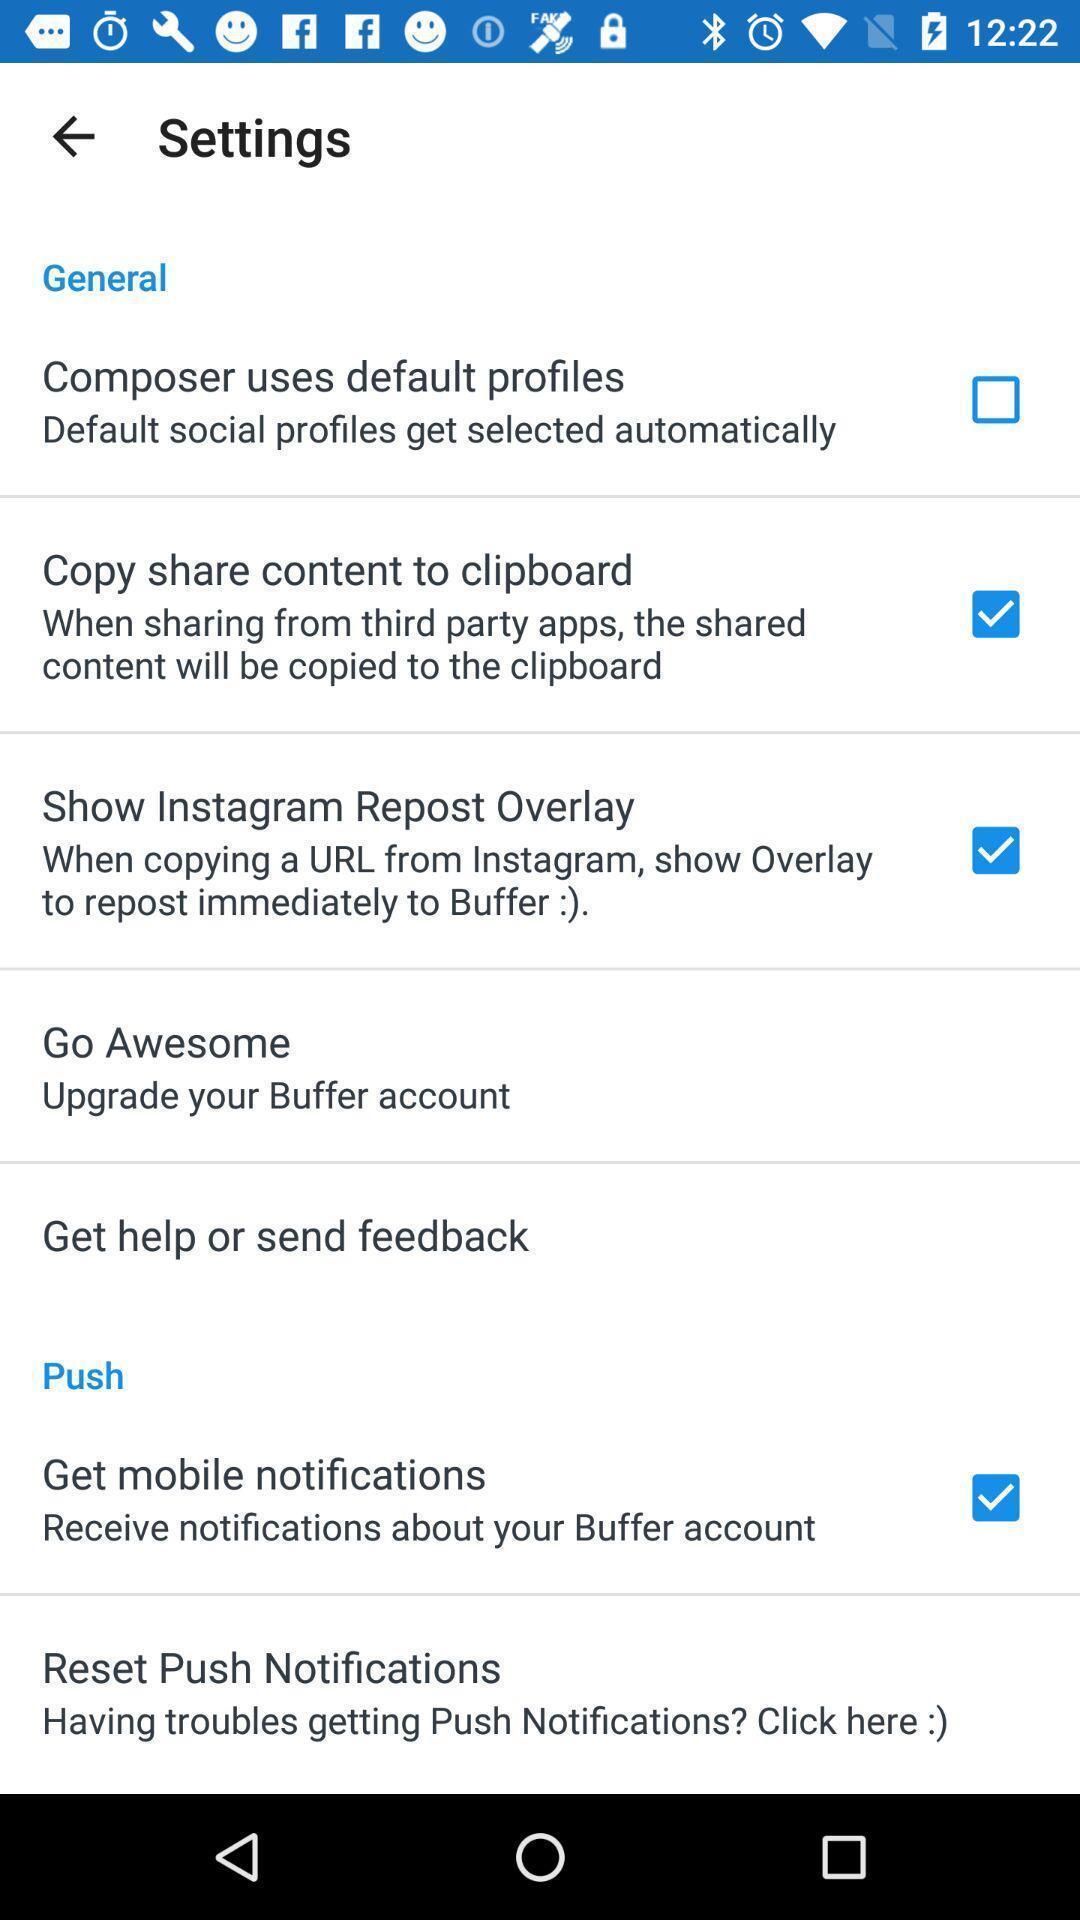Give me a summary of this screen capture. Settings page of a social app. 